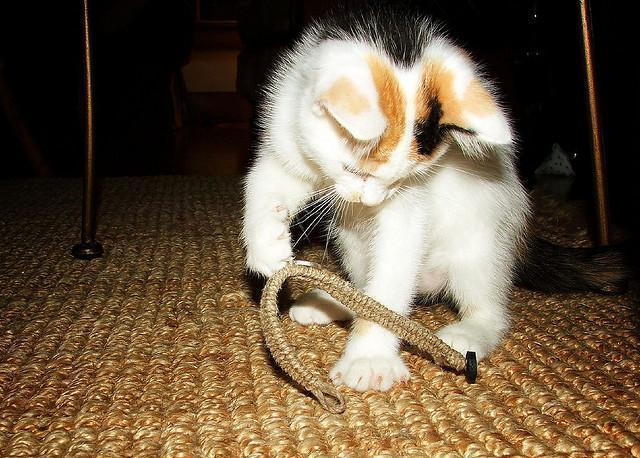How many chairs are green?
Give a very brief answer. 0. 